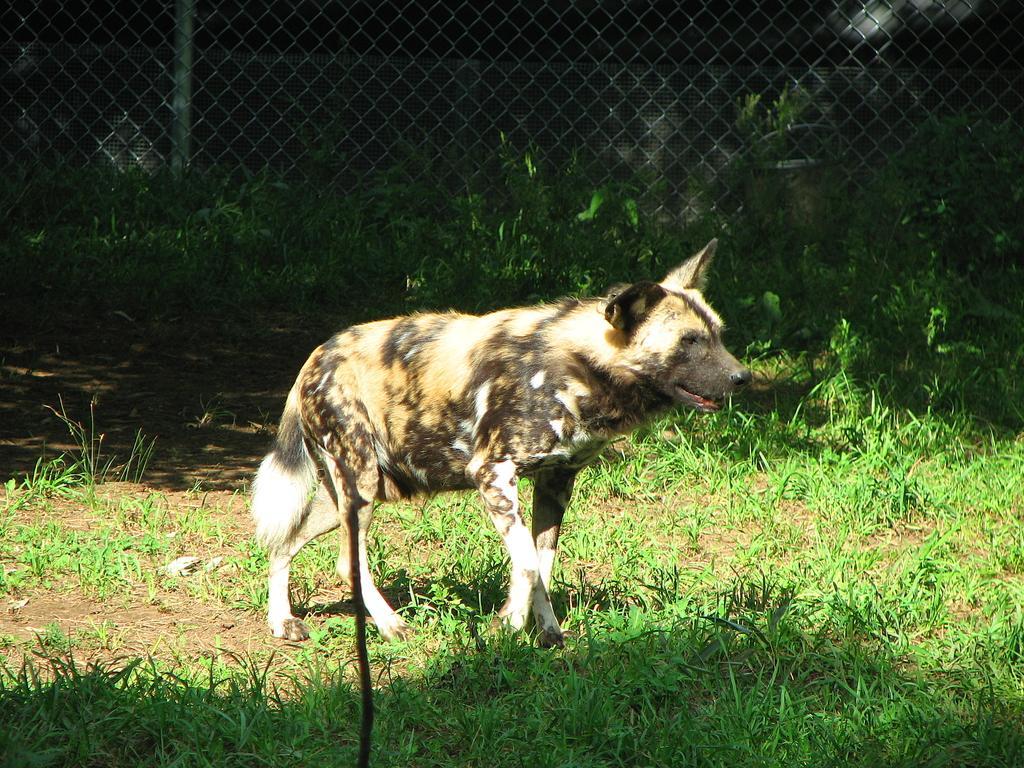Could you give a brief overview of what you see in this image? In the center of the image there is a wild dog. At the bottom there is grass. In the background we can see a mesh. 